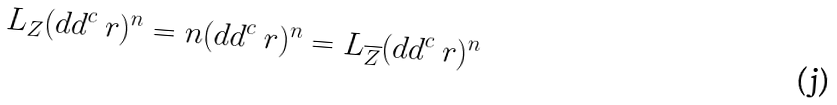<formula> <loc_0><loc_0><loc_500><loc_500>L _ { Z } ( d d ^ { c } \ r ) ^ { n } = n ( d d ^ { c } \ r ) ^ { n } = L _ { \overline { Z } } ( d d ^ { c } \ r ) ^ { n }</formula> 